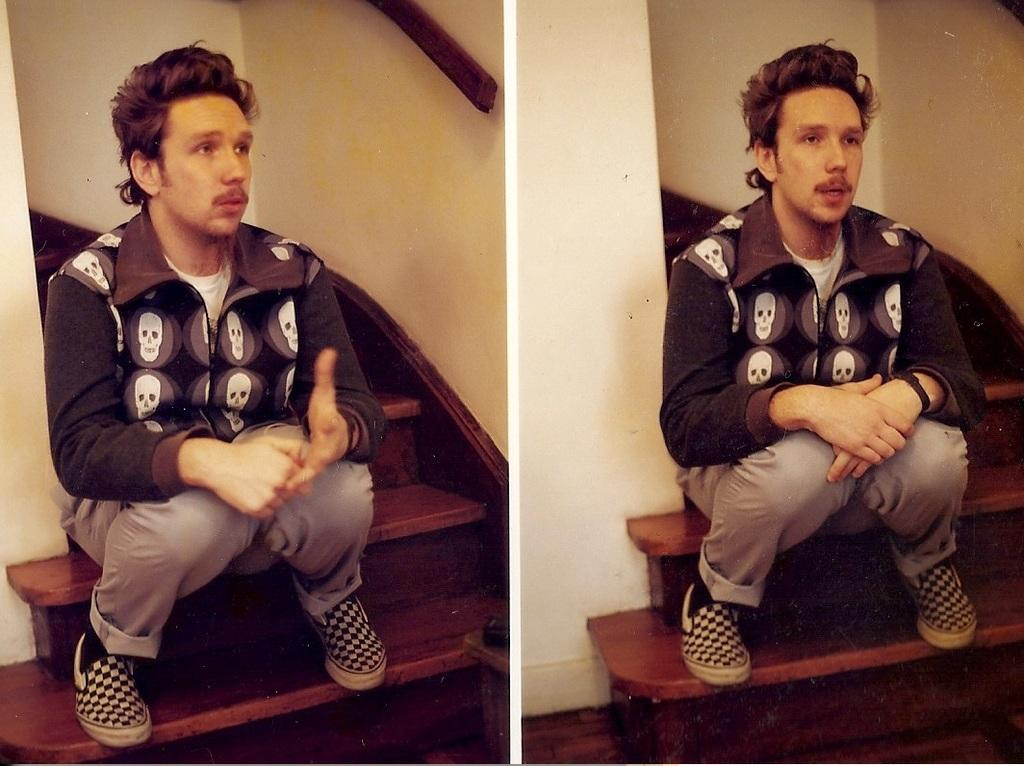Who or what is present in the image? There is a person in the image. What is the person doing in the image? The person is sitting on stairs. What type of mountain is visible in the background of the image? There is no mountain visible in the image; it only features a person sitting on stairs. What does the caption say about the person sitting on stairs? There is no caption present in the image, as it is a still photograph without any accompanying text. 